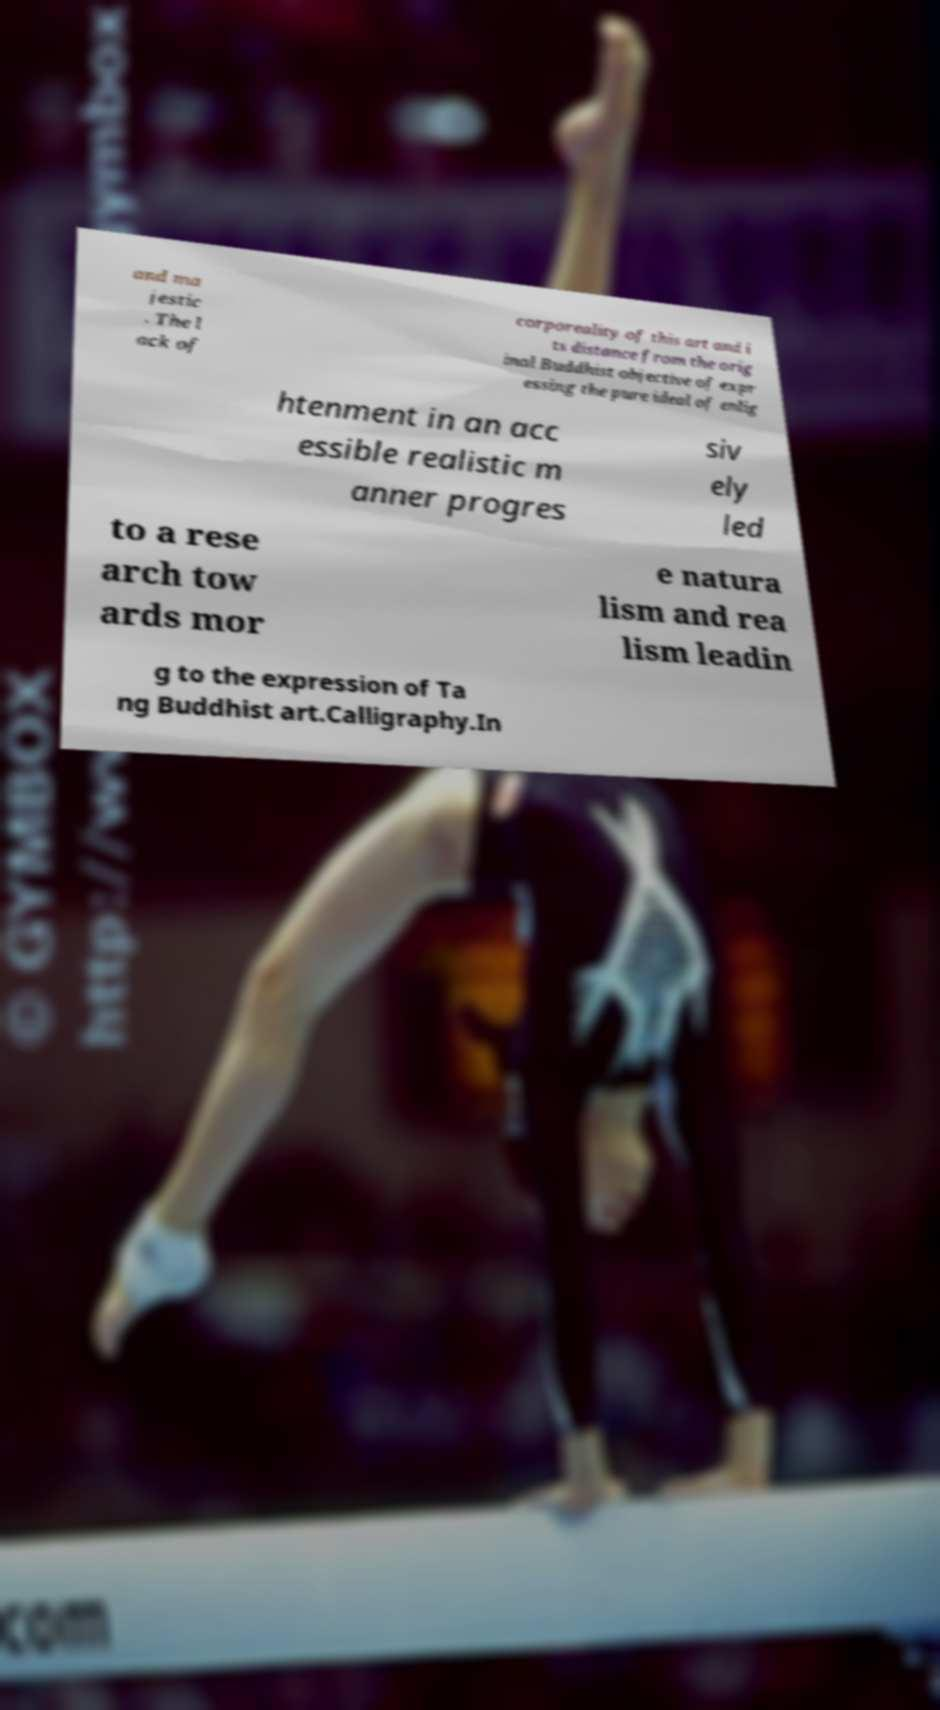For documentation purposes, I need the text within this image transcribed. Could you provide that? and ma jestic . The l ack of corporeality of this art and i ts distance from the orig inal Buddhist objective of expr essing the pure ideal of enlig htenment in an acc essible realistic m anner progres siv ely led to a rese arch tow ards mor e natura lism and rea lism leadin g to the expression of Ta ng Buddhist art.Calligraphy.In 